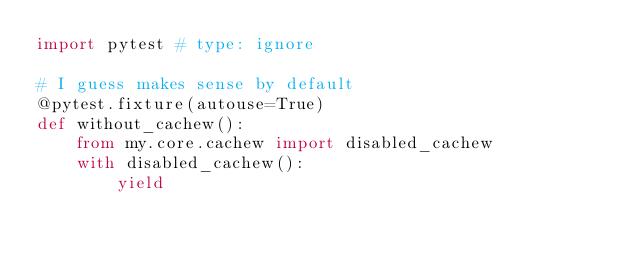<code> <loc_0><loc_0><loc_500><loc_500><_Python_>import pytest # type: ignore

# I guess makes sense by default
@pytest.fixture(autouse=True)
def without_cachew():
    from my.core.cachew import disabled_cachew
    with disabled_cachew():
        yield
</code> 